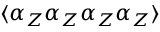Convert formula to latex. <formula><loc_0><loc_0><loc_500><loc_500>\langle \alpha _ { Z } \alpha _ { Z } \alpha _ { Z } \alpha _ { Z } \rangle</formula> 